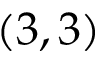Convert formula to latex. <formula><loc_0><loc_0><loc_500><loc_500>\left ( 3 , 3 \right )</formula> 